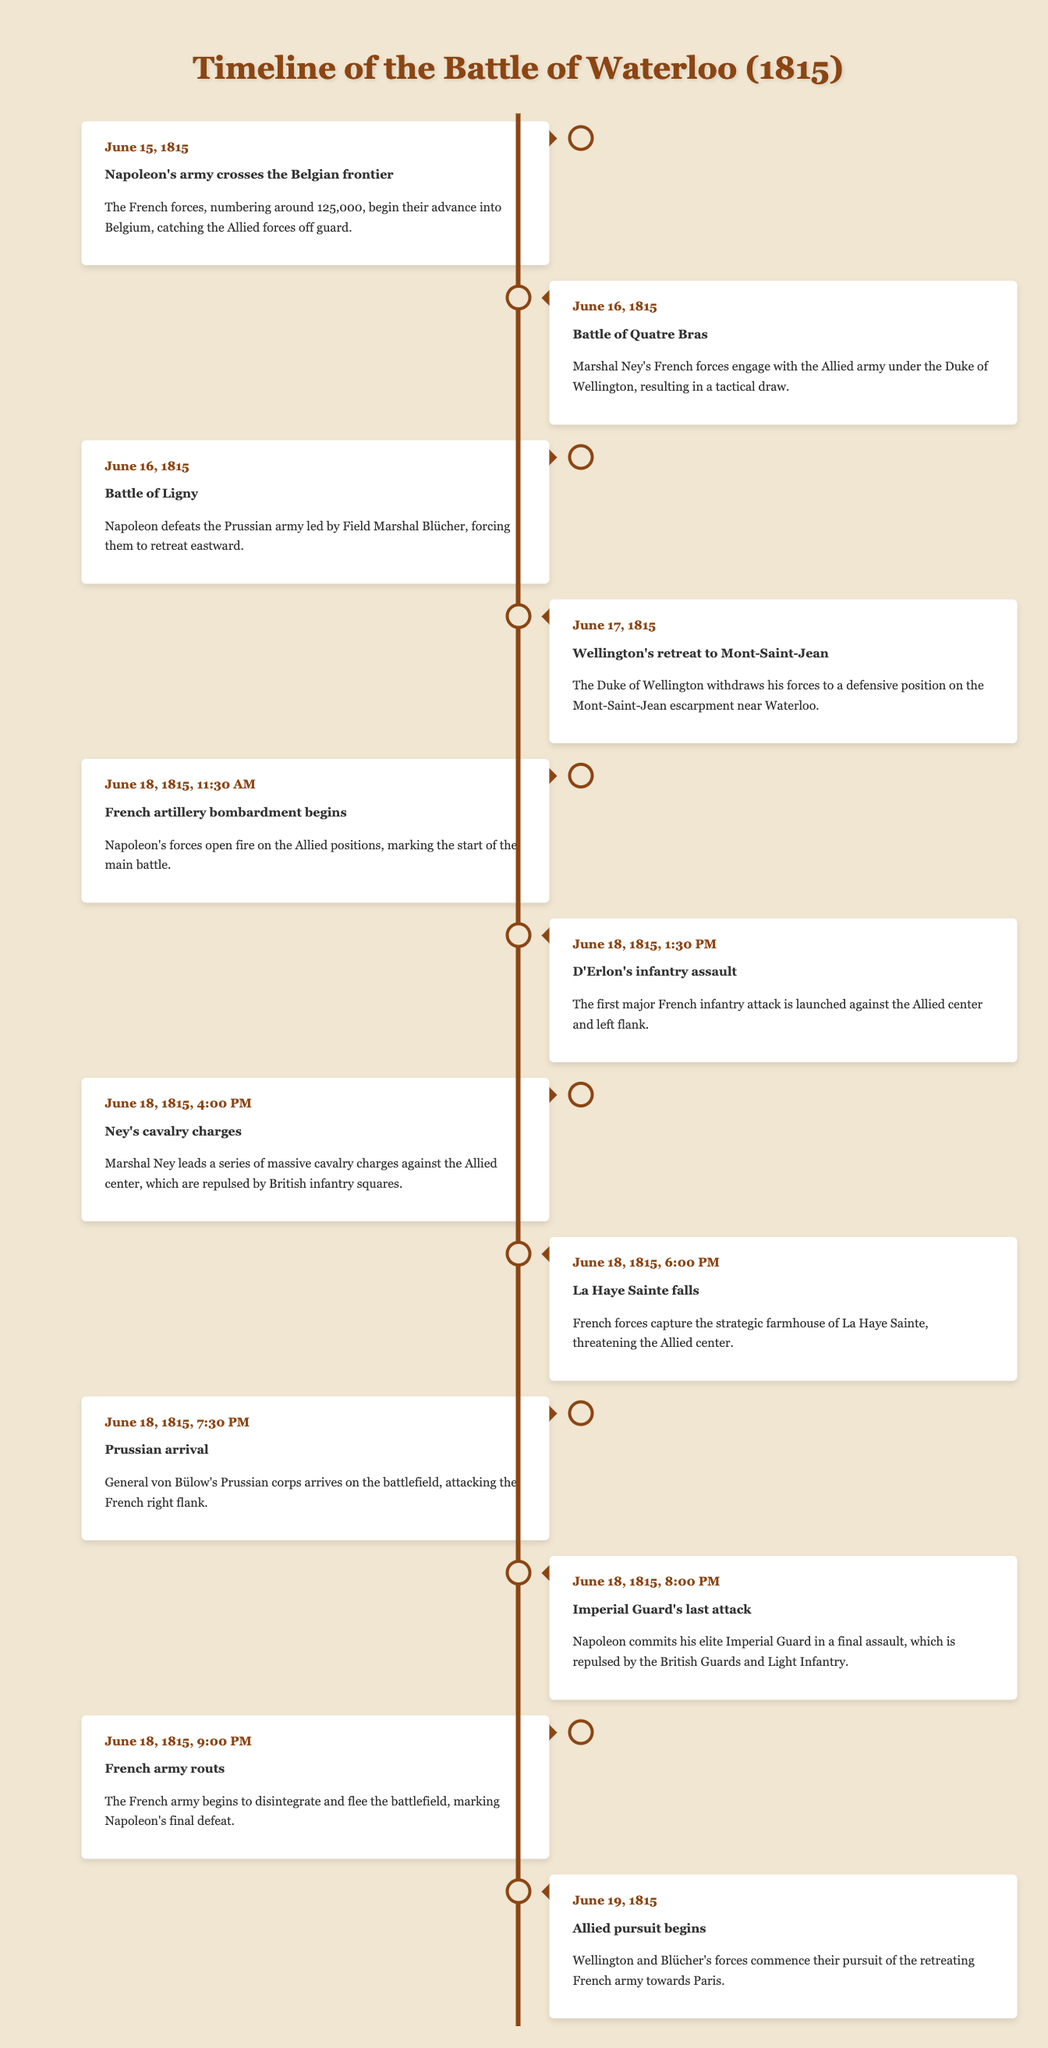What significant event occurred on June 15, 1815? The event that occurred on June 15, 1815, is that Napoleon's army crossed the Belgian frontier. This information can be found in the first row of the table.
Answer: Napoleon's army crosses the Belgian frontier How many major battles occurred on June 16, 1815? There are two major battles listed on June 16, 1815: the Battle of Quatre Bras and the Battle of Ligny. This can be seen by counting the events in the table that occurred on this date.
Answer: 2 Was the Battle of Ligny a victory for Napoleon? Yes, the Battle of Ligny was a victory for Napoleon, as the description states that he defeated the Prussian army led by Field Marshal Blücher. This is confirmed by the entry for the Battle of Ligny in the table.
Answer: Yes What time did the French artillery bombardment begin on June 18, 1815? The French artillery bombardment began at 11:30 AM on June 18, 1815, as stated in the corresponding entry in the table.
Answer: 11:30 AM Which event marked the beginning of the Allied pursuit and on what date did it start? The event that marked the beginning of the Allied pursuit was on June 19, 1815, as stated in the last entry of the table. This involved Wellington and Blücher's forces pursuing the retreating French army.
Answer: June 19, 1815 What was the outcome of Ney's cavalry charges in the Battle of Waterloo? Ney's cavalry charges were repulsed by the British infantry squares, according to the description in the table. Thus, it indicates that the charges did not succeed.
Answer: Repulsed How did the events of June 18, 1815, change the course of the battle? On June 18, 1815, several significant events occurred, including the French bombardment, D'Erlon's assault, Ney's cavalry charges, and the arrival of the Prussians. These cumulatively affected the course of the battle, leading to the French army's eventual rout later that evening. Recognizing how these developments unfolded indicates their collective impact in determining the outcome of the battle.
Answer: French army was routed What was the significance of La Haye Sainte during the battle? La Haye Sainte was significant because its capture by French forces at 6:00 PM on June 18, 1815, threatened the Allied center, which shows its strategic importance in the battle, as highlighted in the table.
Answer: Strategic importance in the battle How many hours passed between the start of the French artillery bombardment and the French army rout? The French artillery bombardment began at 11:30 AM and the rout occurred at 9:00 PM on June 18, 1815. Calculating the time from 11:30 AM to 9:00 PM gives us a total of 9.5 hours. We determine this by figuring the hours between the times: from 11:30 AM to 9:00 PM is 9 hours and 30 minutes.
Answer: 9.5 hours 